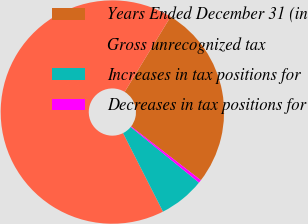Convert chart. <chart><loc_0><loc_0><loc_500><loc_500><pie_chart><fcel>Years Ended December 31 (in<fcel>Gross unrecognized tax<fcel>Increases in tax positions for<fcel>Decreases in tax positions for<nl><fcel>26.72%<fcel>66.21%<fcel>6.63%<fcel>0.44%<nl></chart> 